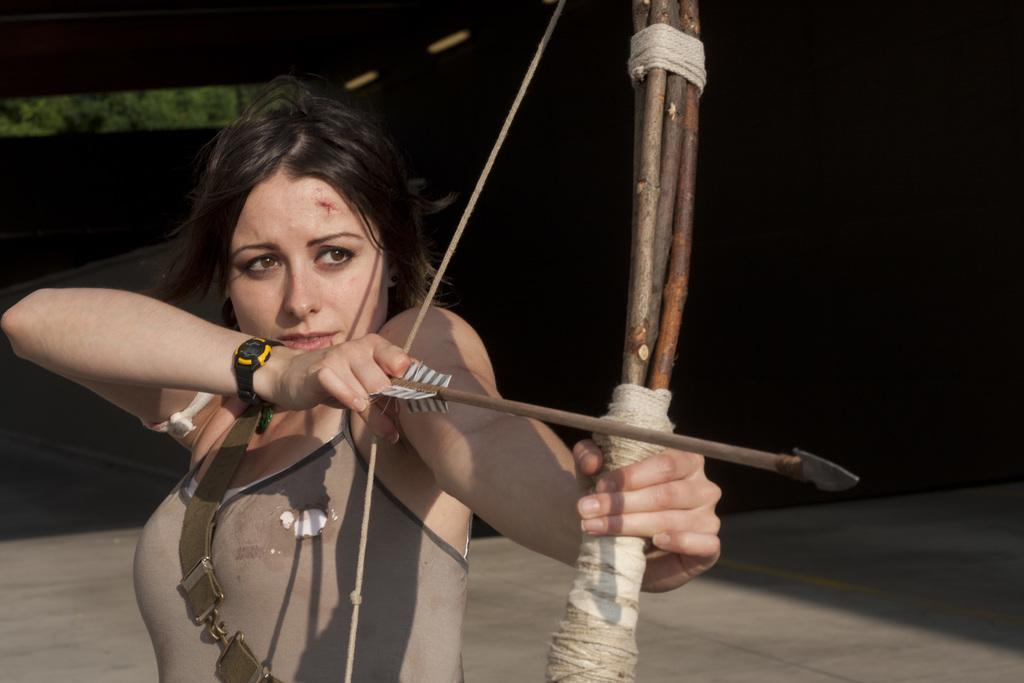What is the main subject of the image? There is a woman in the image. What is the woman wearing on her wrist? The woman is wearing a watch. What is the woman's posture in the image? The woman is standing. What objects is the woman holding in the image? The woman is holding a bow and an arrow. What can be seen in the background of the image? There is a ground visible in the background of the image. What is the color of the background in the image? The background of the image is black. Can you tell me how many eyes the guide has in the image? There is no guide present in the image, and therefore no eyes to count. What type of winter clothing is the woman wearing in the image? The image does not show the woman wearing any winter clothing, as the facts provided do not mention any such items. 